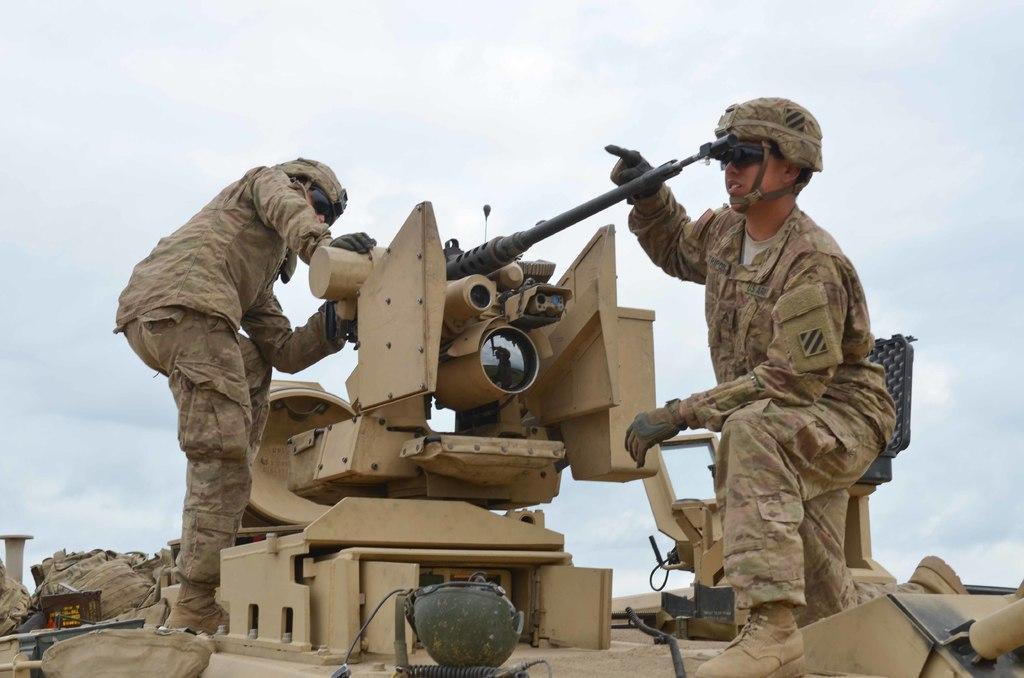How would you summarize this image in a sentence or two? In this image we can able to see two military persons on the tanker, there is a helmet and bags on it, and we can see the sky. 